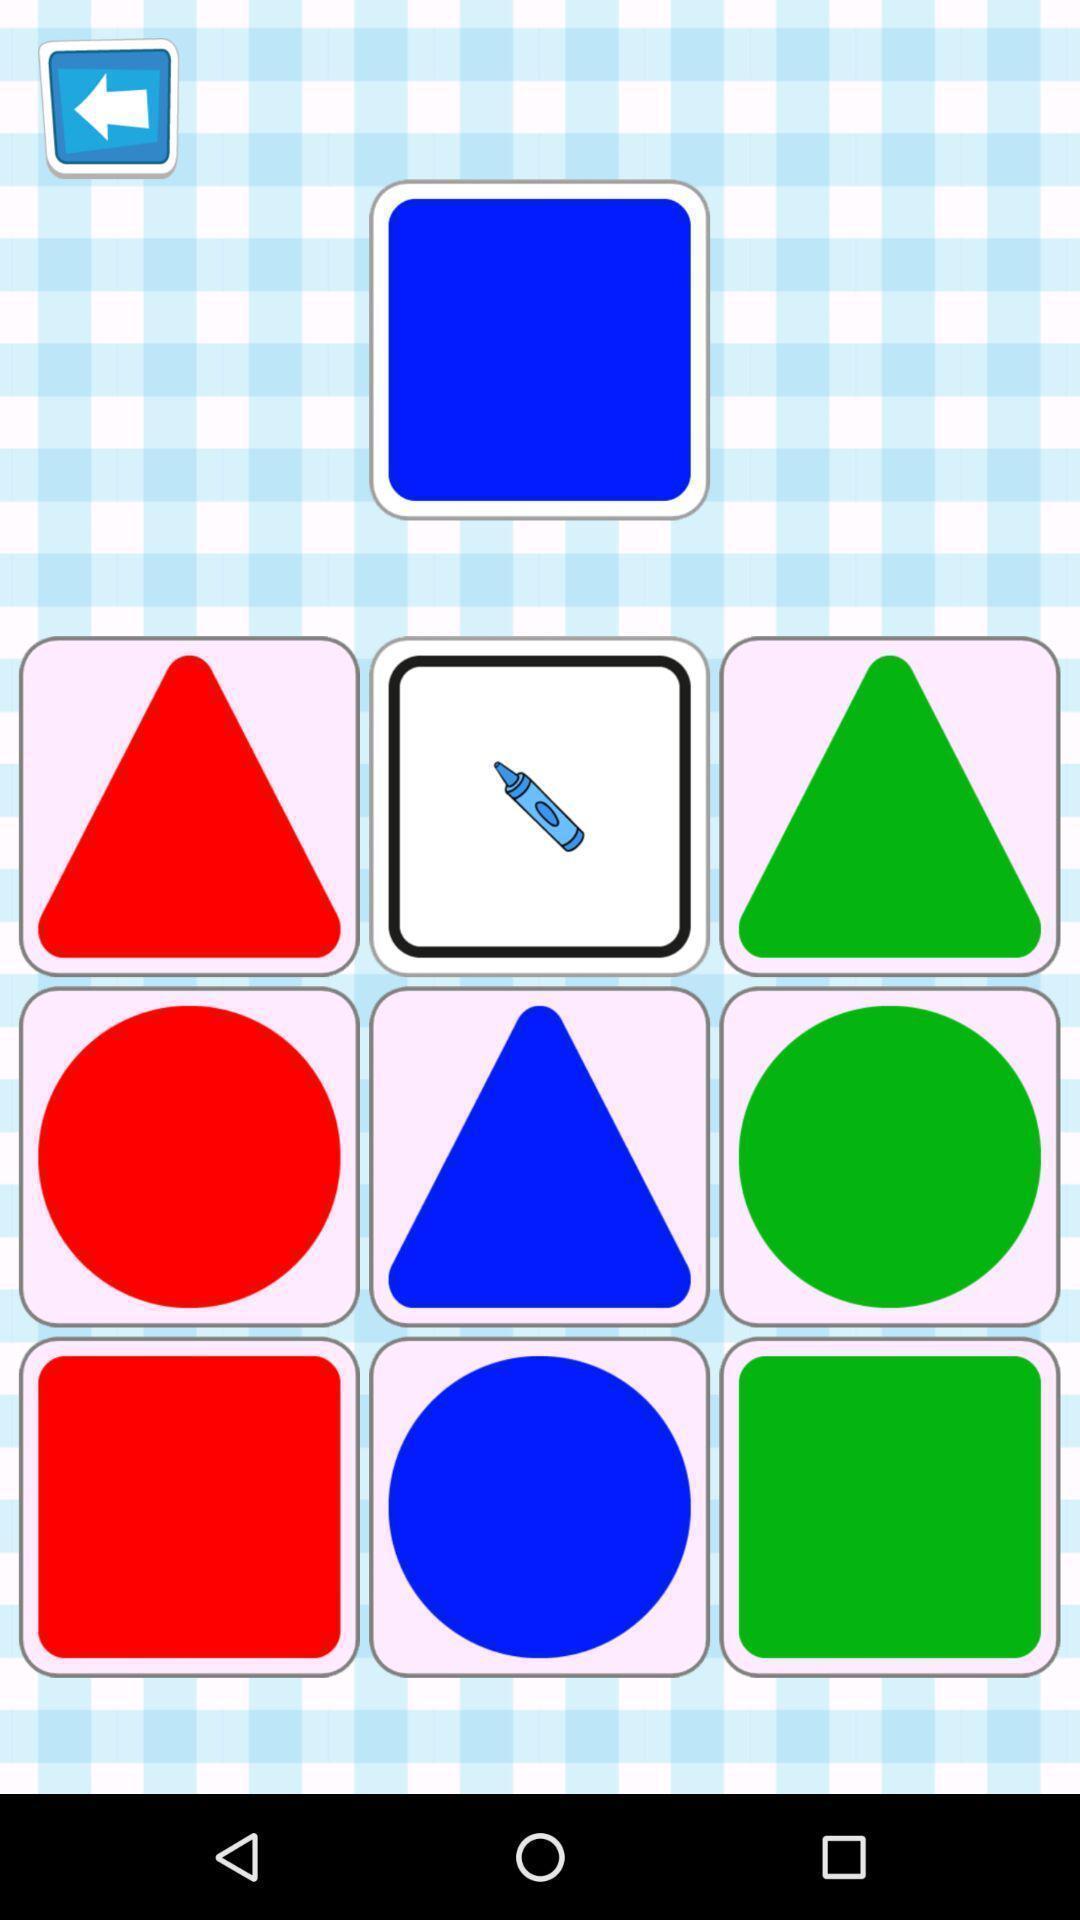Summarize the main components in this picture. Various polygons with differ colors displayed of a gaming app. 